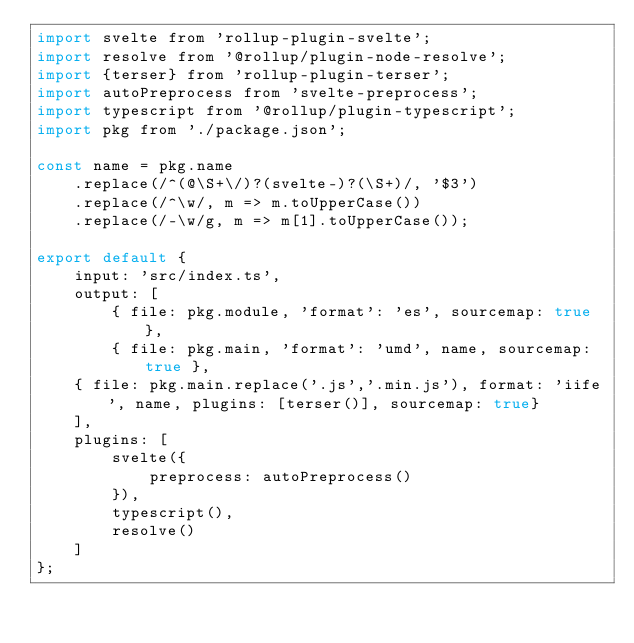<code> <loc_0><loc_0><loc_500><loc_500><_JavaScript_>import svelte from 'rollup-plugin-svelte';
import resolve from '@rollup/plugin-node-resolve';
import {terser} from 'rollup-plugin-terser';
import autoPreprocess from 'svelte-preprocess';
import typescript from '@rollup/plugin-typescript';
import pkg from './package.json';

const name = pkg.name
	.replace(/^(@\S+\/)?(svelte-)?(\S+)/, '$3')
	.replace(/^\w/, m => m.toUpperCase())
	.replace(/-\w/g, m => m[1].toUpperCase());

export default {
	input: 'src/index.ts',
	output: [
		{ file: pkg.module, 'format': 'es', sourcemap: true },
		{ file: pkg.main, 'format': 'umd', name, sourcemap: true },
    { file: pkg.main.replace('.js','.min.js'), format: 'iife', name, plugins: [terser()], sourcemap: true}
	],
	plugins: [
		svelte({
			preprocess: autoPreprocess()
		}),
		typescript(),
		resolve()
	]
};
</code> 